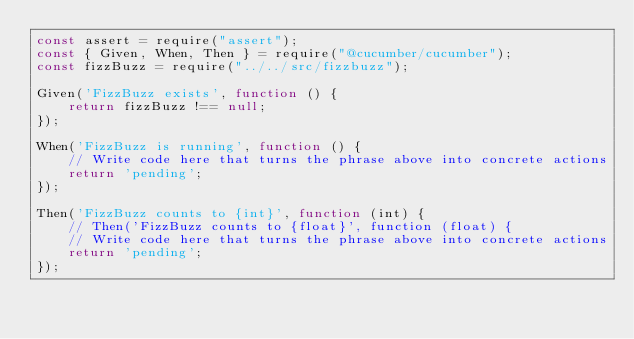Convert code to text. <code><loc_0><loc_0><loc_500><loc_500><_JavaScript_>const assert = require("assert");
const { Given, When, Then } = require("@cucumber/cucumber");
const fizzBuzz = require("../../src/fizzbuzz");

Given('FizzBuzz exists', function () {
    return fizzBuzz !== null;
});

When('FizzBuzz is running', function () {
    // Write code here that turns the phrase above into concrete actions
    return 'pending';
});

Then('FizzBuzz counts to {int}', function (int) {
    // Then('FizzBuzz counts to {float}', function (float) {
    // Write code here that turns the phrase above into concrete actions
    return 'pending';
});
</code> 